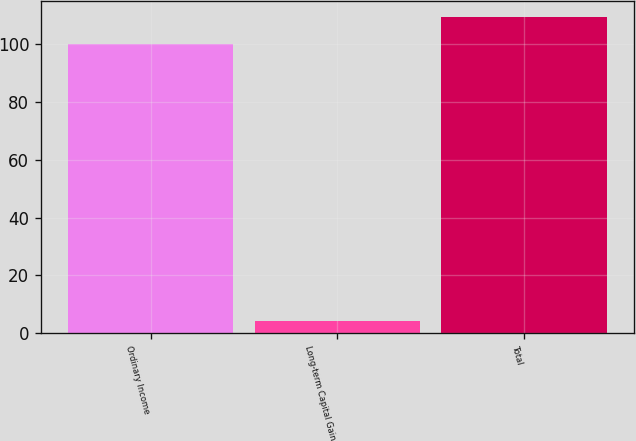Convert chart to OTSL. <chart><loc_0><loc_0><loc_500><loc_500><bar_chart><fcel>Ordinary Income<fcel>Long-term Capital Gain<fcel>Total<nl><fcel>100<fcel>4.09<fcel>109.59<nl></chart> 